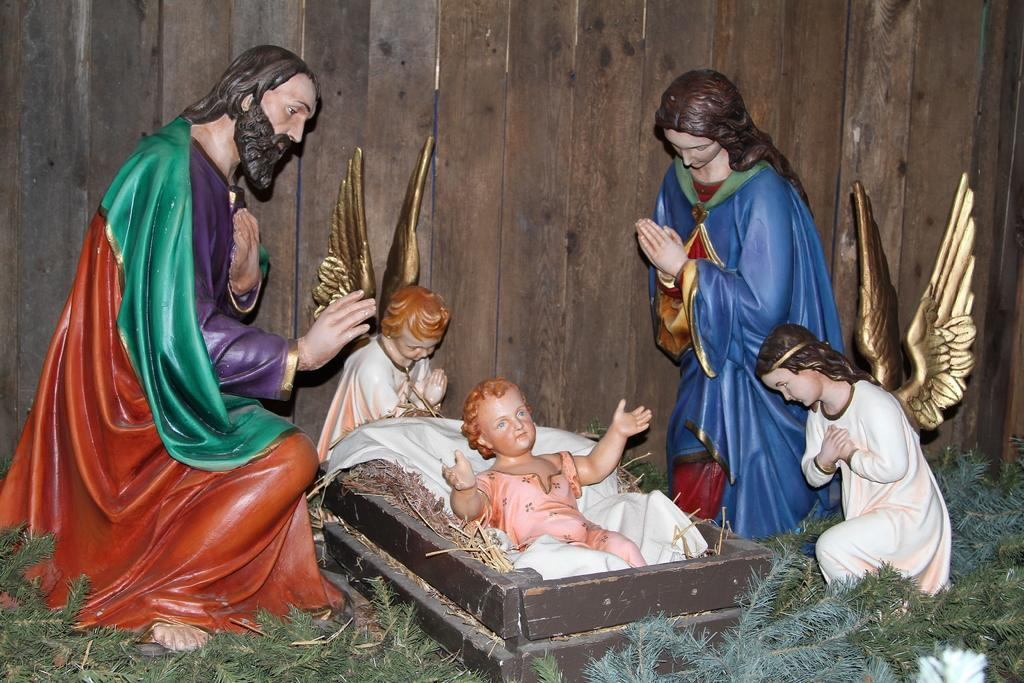What can be found at the bottom of the image? There are statues and a grassy ground in the bottom of the image. What type of material is used for the wall in the background? The wall in the background of the image is made of wood. How many arguments are taking place in the image? There are no arguments present in the image. What type of hose can be seen connected to the wooden wall in the image? There is no hose present in the image. 